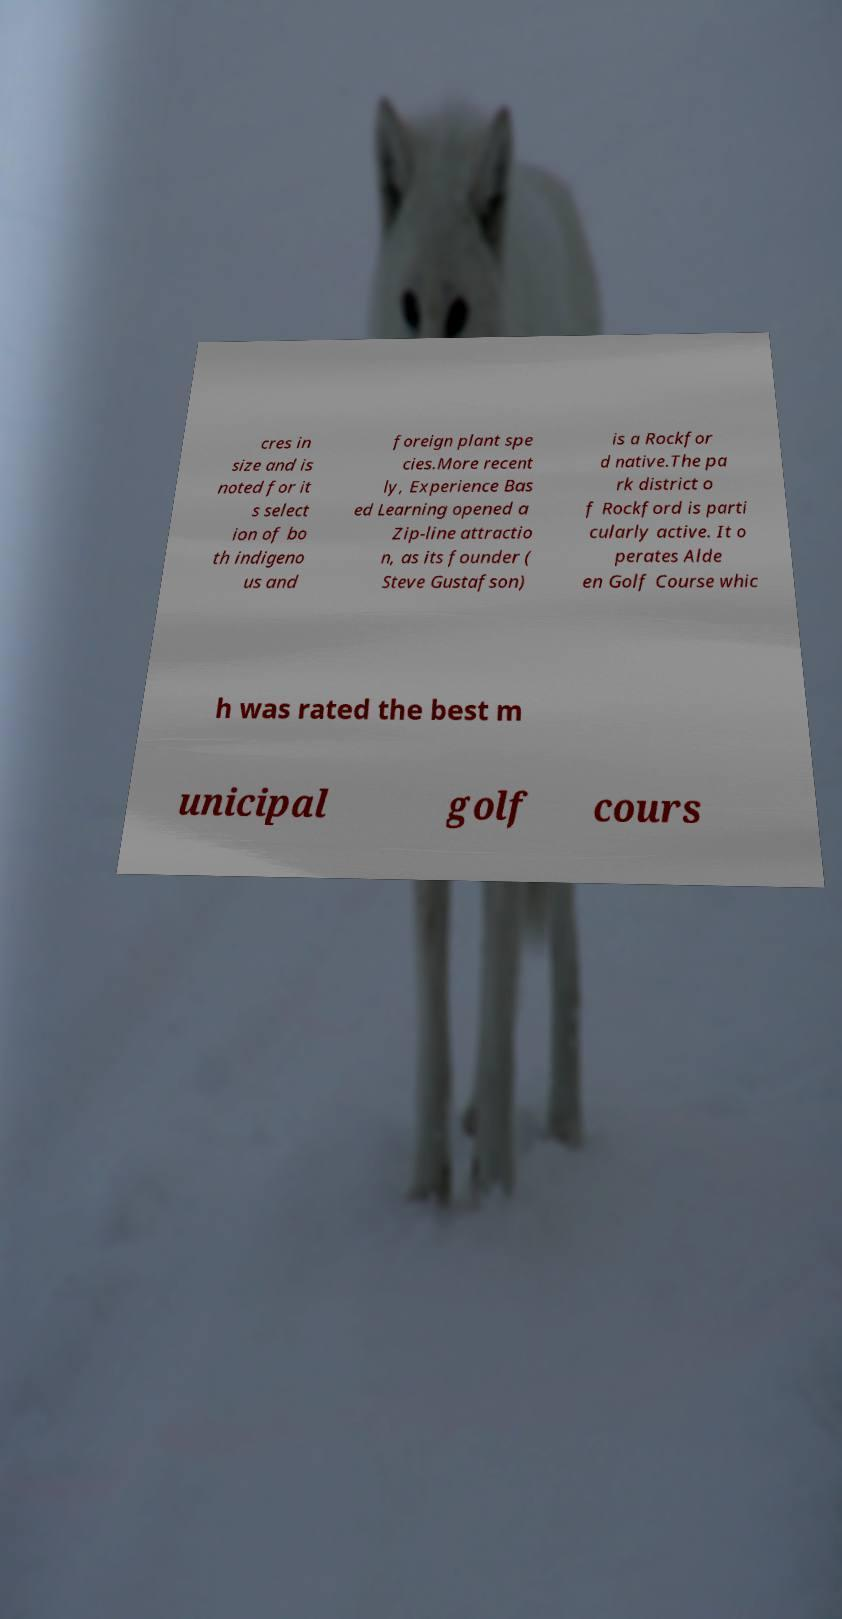Could you assist in decoding the text presented in this image and type it out clearly? cres in size and is noted for it s select ion of bo th indigeno us and foreign plant spe cies.More recent ly, Experience Bas ed Learning opened a Zip-line attractio n, as its founder ( Steve Gustafson) is a Rockfor d native.The pa rk district o f Rockford is parti cularly active. It o perates Alde en Golf Course whic h was rated the best m unicipal golf cours 